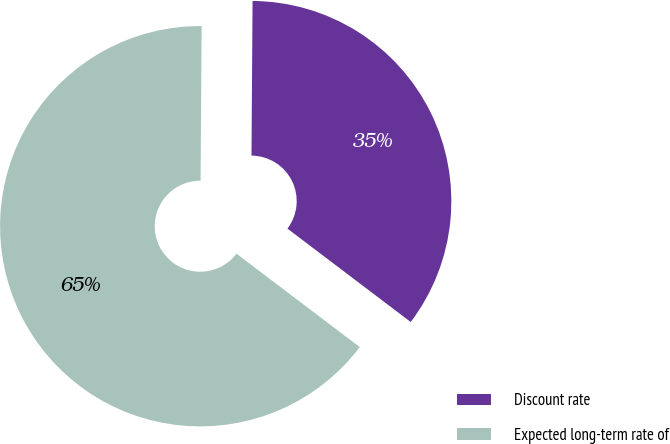<chart> <loc_0><loc_0><loc_500><loc_500><pie_chart><fcel>Discount rate<fcel>Expected long-term rate of<nl><fcel>35.21%<fcel>64.79%<nl></chart> 